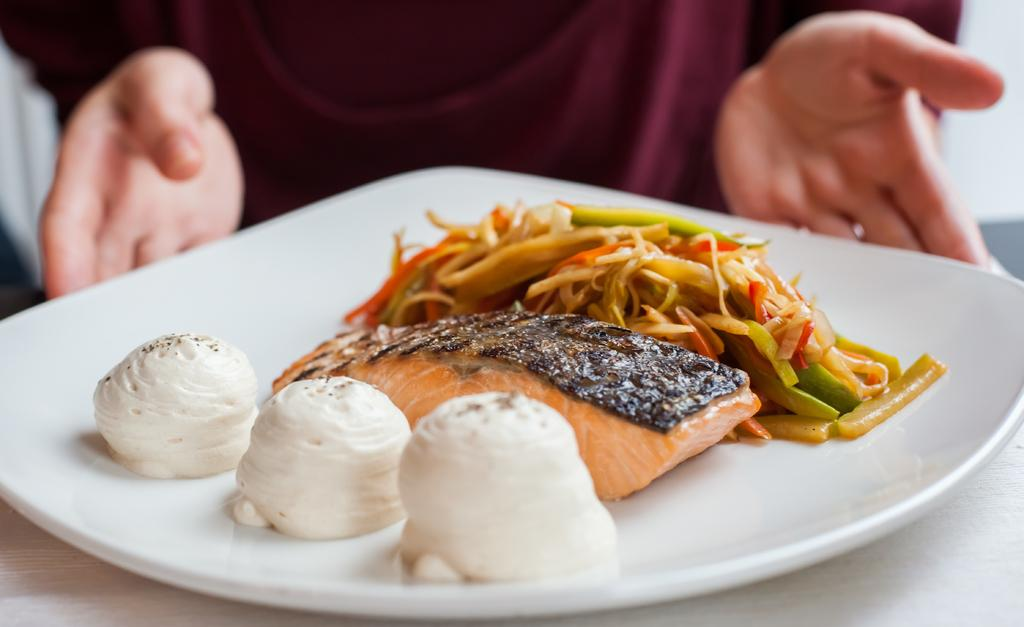What can be seen in the image? There is a person in the image. What is the person holding? The person is holding a plate. What is on the plate? The plate contains food items. On what surface is the plate placed? The plate is placed on a wooden surface. What type of ornament is hanging from the person's neck in the image? There is no ornament visible around the person's neck in the image. Can you see any chickens in the image? There are no chickens present in the image. 